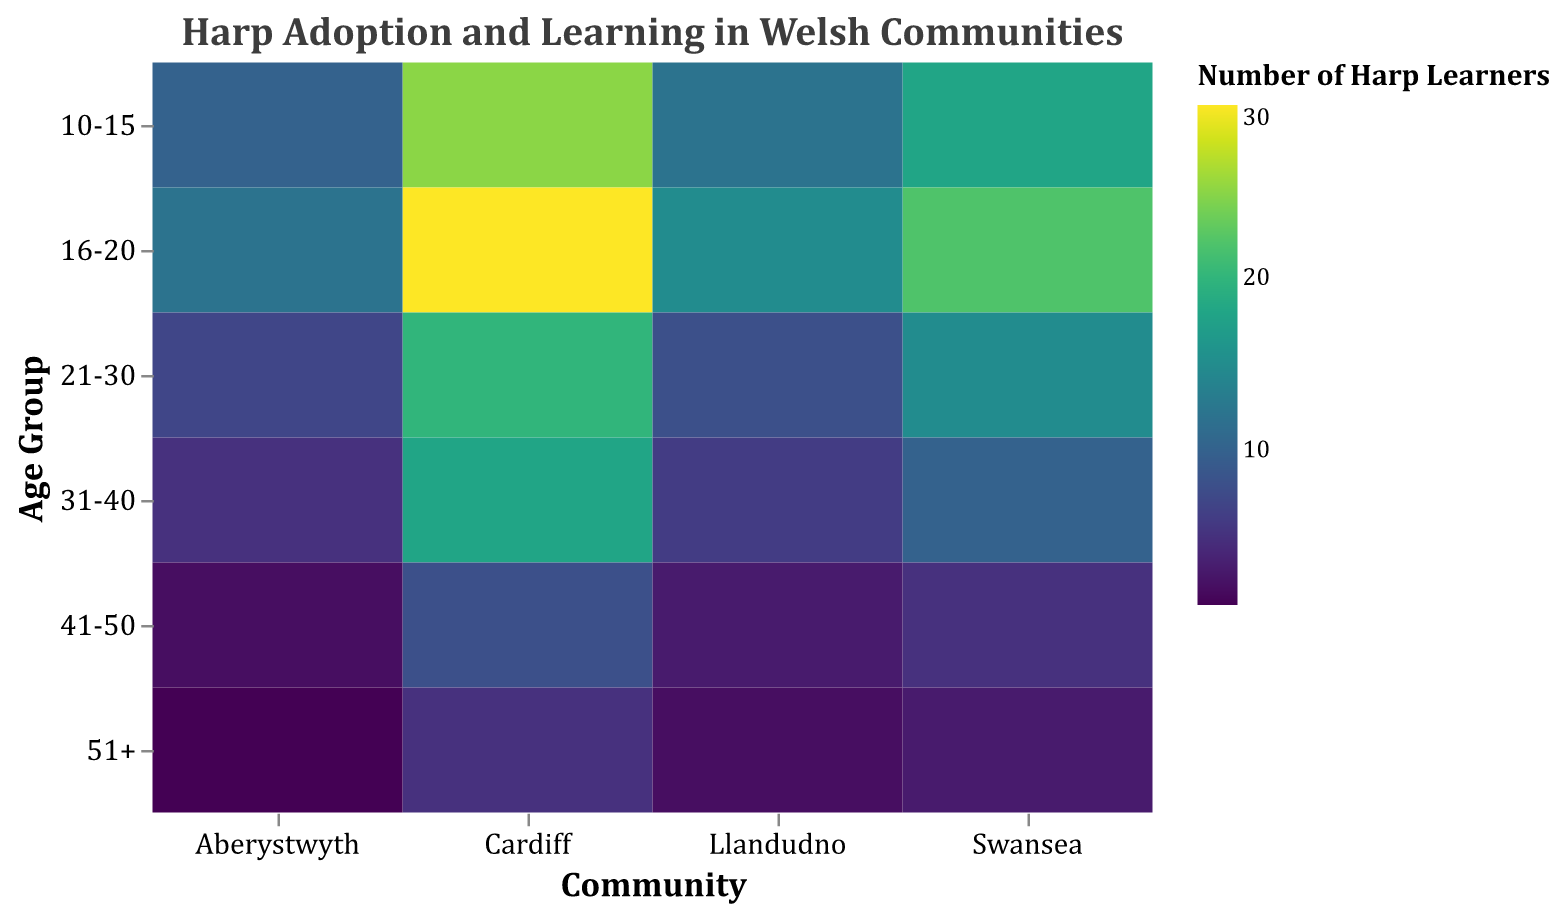What is the title of the heatmap? The title of the heatmap is displayed at the top of the plot in a larger font size. It reads "Harp Adoption and Learning in Welsh Communities."
Answer: Harp Adoption and Learning in Welsh Communities Which age group in Cardiff has the highest number of harp learners? By looking at the cells for the Cardiff column, the cell with the darkest color for the age group "16-20" has the highest value of 30 harp learners.
Answer: 16-20 What is the number of harp learners and harps available for the age group 31-40 in Swansea? The cell corresponding to Swansea and the age group 31-40 shows the tooltip with values for harp learners and harps available. It has 10 harp learners and 7 harps available.
Answer: 10 harp learners, 7 harps available Which community has the lowest number of harp learners in the age group 51+? By inspecting the 51+ row, the cell with the lightest color indicates the lowest value. Aberystwyth has the lowest number with only 1 harp learner.
Answer: Aberystwyth Compare the number of harp learners between the 10-15 and 21-30 age groups in Llandudno. Which is higher? The cells for Llandudno in the age groups 10-15 and 21-30 are compared. The 10-15 group has 12 harp learners, while the 21-30 group has 8. Therefore, the 10-15 age group has more harp learners.
Answer: 10-15 What is the total number of harps available in Cardiff across all age groups? Sum the values of the "number_of_harps_available" in Cardiff: 15 (10-15) + 20 (16-20) + 12 (21-30) + 10 (31-40) + 5 (41-50) + 2 (51+). The sum is 64.
Answer: 64 Which age group shows the highest number of harp learners across all communities? By evaluating each row corresponding to different age groups, the age group 16-20 shows the highest values across multiple communities, indicating the highest number of harp learners in aggregate.
Answer: 16-20 Is the number of harp learners higher for the 41-50 age group in Aberystwyth than in Llandudno? Compare the cells for Aberystwyth and Llandudno in the 41-50 age group. Aberystwyth has 2 learners, while Llandudno has 3, meaning Llandudno has more.
Answer: No 